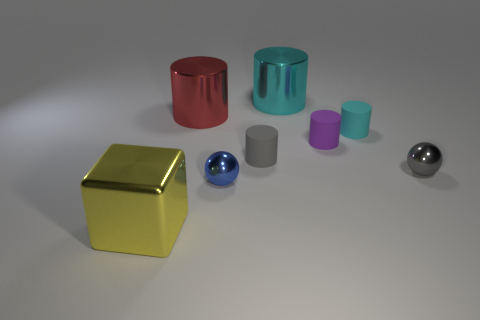Subtract all gray cylinders. How many cylinders are left? 4 Subtract all large cyan metallic cylinders. How many cylinders are left? 4 Subtract all red cylinders. Subtract all purple balls. How many cylinders are left? 4 Add 2 rubber cylinders. How many objects exist? 10 Subtract all cylinders. How many objects are left? 3 Add 7 spheres. How many spheres are left? 9 Add 5 purple matte cylinders. How many purple matte cylinders exist? 6 Subtract 1 blue balls. How many objects are left? 7 Subtract all tiny gray matte cylinders. Subtract all tiny gray rubber cylinders. How many objects are left? 6 